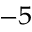Convert formula to latex. <formula><loc_0><loc_0><loc_500><loc_500>^ { - 5 }</formula> 